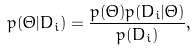Convert formula to latex. <formula><loc_0><loc_0><loc_500><loc_500>p ( \Theta | D _ { i } ) = \frac { p ( \Theta ) p ( D _ { i } | \Theta ) } { p ( D _ { i } ) } ,</formula> 